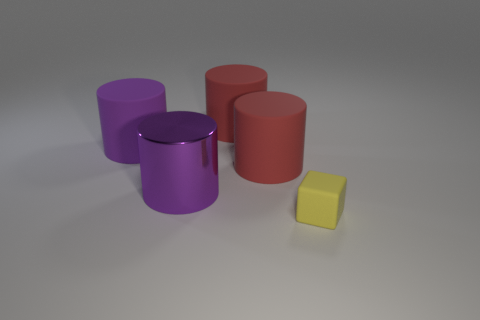Can you describe the colors of the cylindrical objects? Certainly! From left to right, the cylindrical objects are purple, red, and a distinct reddish color similar to coral. Their colors add to the visual interest of the scene. 